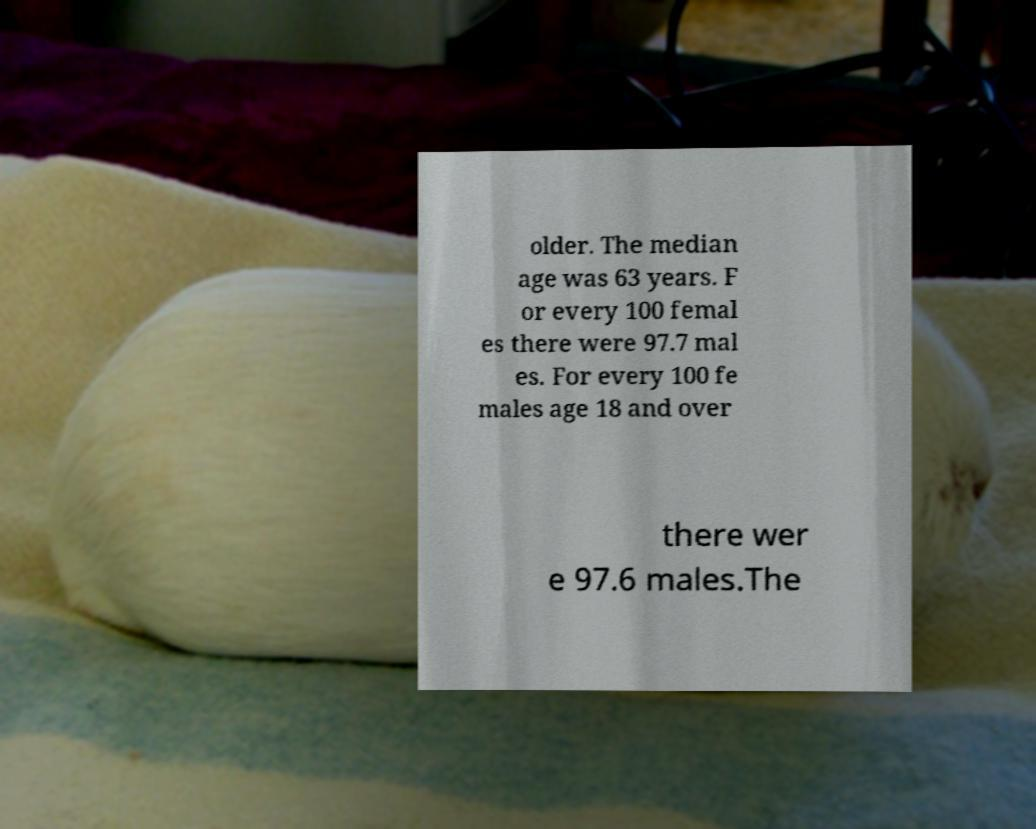Could you extract and type out the text from this image? older. The median age was 63 years. F or every 100 femal es there were 97.7 mal es. For every 100 fe males age 18 and over there wer e 97.6 males.The 